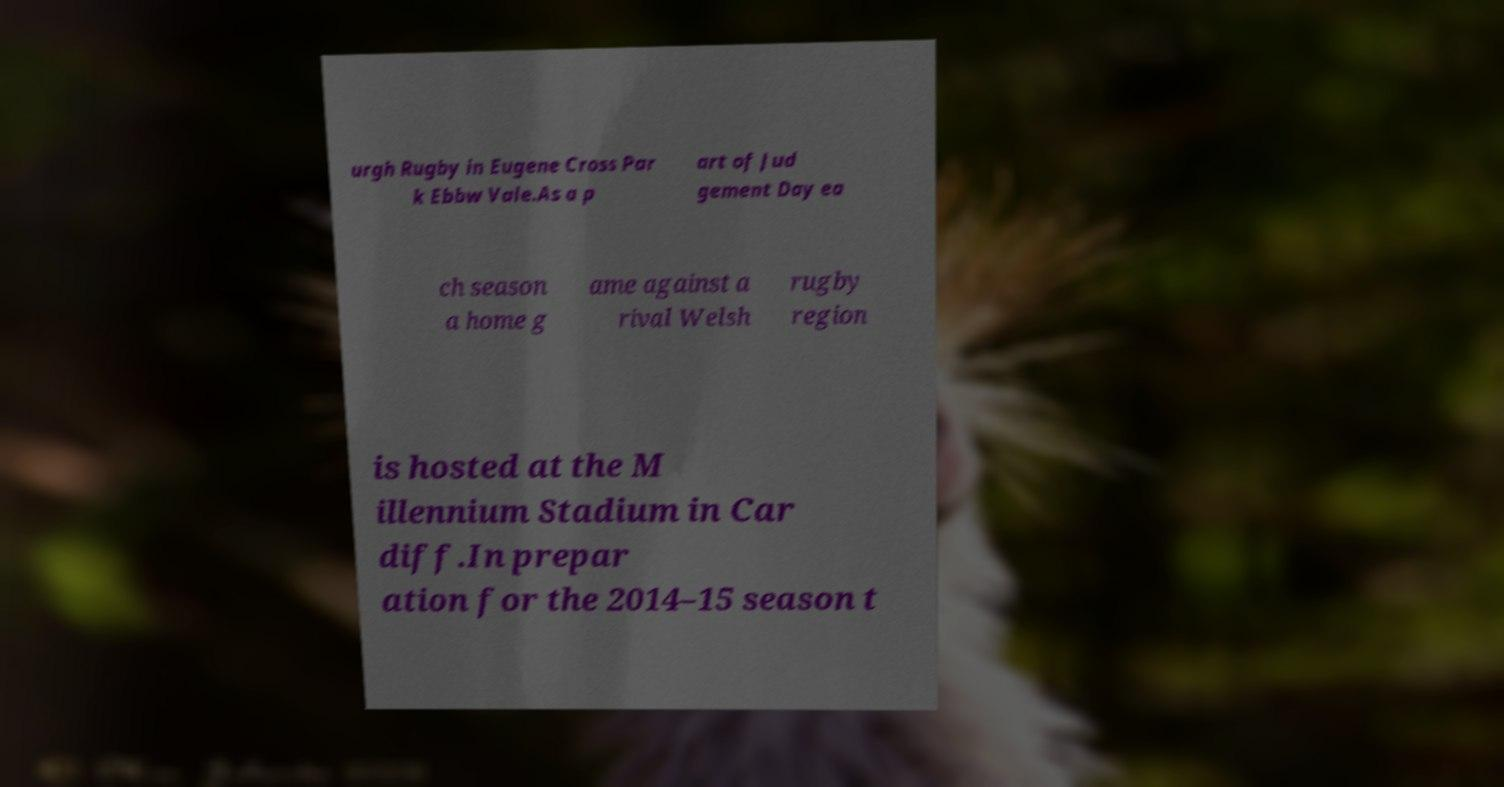I need the written content from this picture converted into text. Can you do that? urgh Rugby in Eugene Cross Par k Ebbw Vale.As a p art of Jud gement Day ea ch season a home g ame against a rival Welsh rugby region is hosted at the M illennium Stadium in Car diff.In prepar ation for the 2014–15 season t 